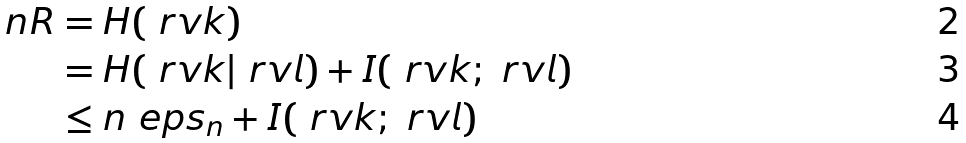Convert formula to latex. <formula><loc_0><loc_0><loc_500><loc_500>n R & = H ( \ r v k ) \\ & = H ( \ r v k | \ r v l ) + I ( \ r v k ; \ r v l ) \\ & \leq n \ e p s _ { n } + I ( \ r v k ; \ r v l )</formula> 